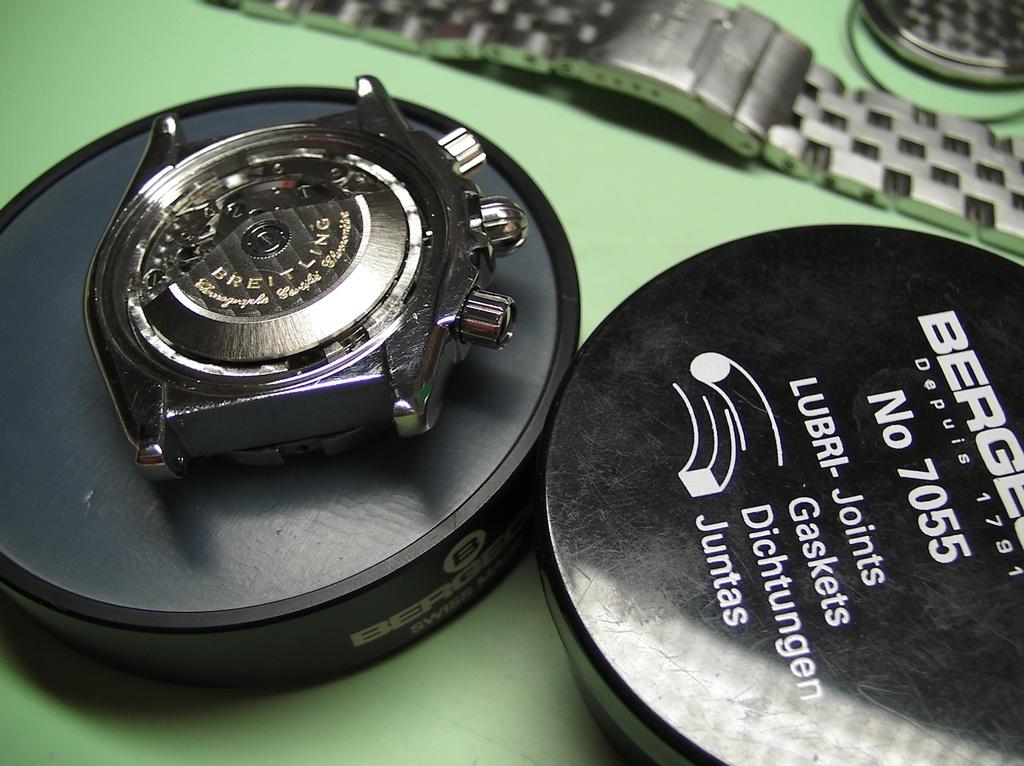What year was this company established?
Make the answer very short. 1791. 